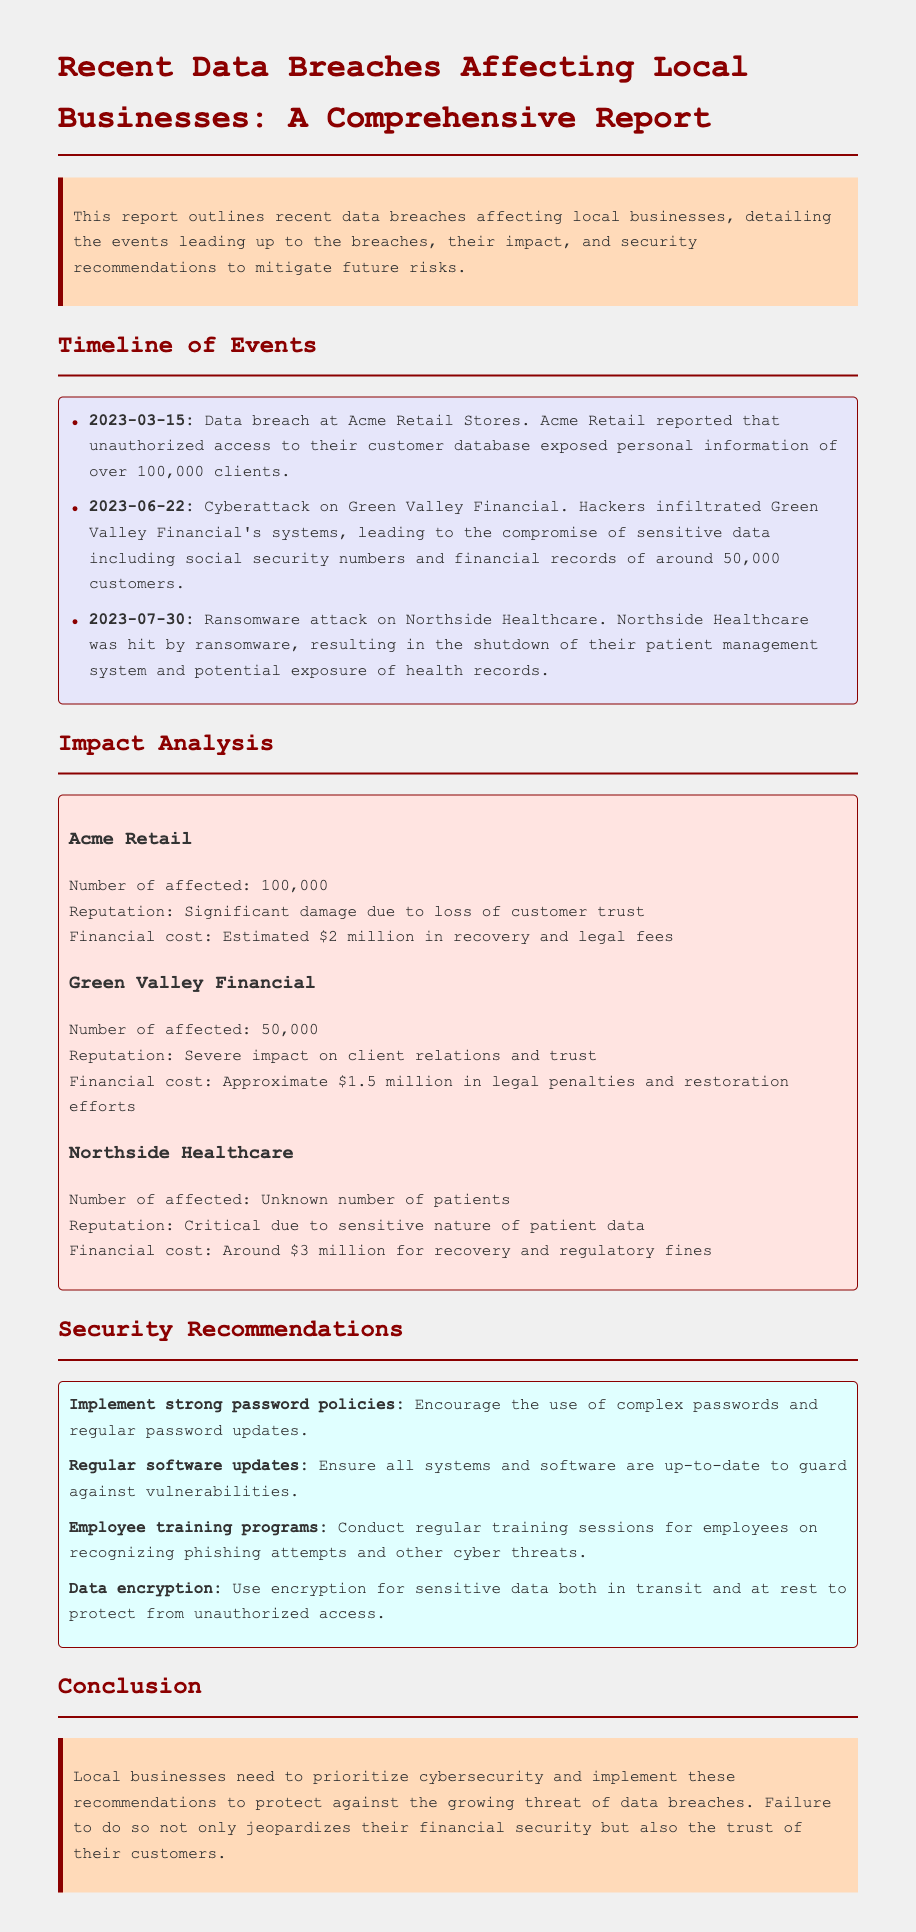What date did the data breach at Acme Retail occur? The document specifies the date of the data breach at Acme Retail as March 15, 2023.
Answer: March 15, 2023 How many customers were affected by the breach at Green Valley Financial? The document states that the breach at Green Valley Financial compromised sensitive data of around 50,000 customers.
Answer: 50,000 What was the estimated financial cost of the breach at Northside Healthcare? The document mentions that the estimated financial cost for Northside Healthcare's breach was around $3 million for recovery and regulatory fines.
Answer: $3 million Which local business suffered significant damage to its reputation? The document indicates that Acme Retail experienced significant damage due to loss of customer trust.
Answer: Acme Retail What is one of the security recommendations given in the report? The document includes several security recommendations, one of which is to implement strong password policies.
Answer: Implement strong password policies How many data breaches were reported in the timeline? The timeline presents three data breaches affecting local businesses.
Answer: Three What type of attack was reported against Northside Healthcare? The document describes the nature of the attack on Northside Healthcare as a ransomware attack.
Answer: Ransomware attack What was the overall recommendation for local businesses? The document concludes with the recommendation that local businesses prioritize cybersecurity.
Answer: Prioritize cybersecurity 